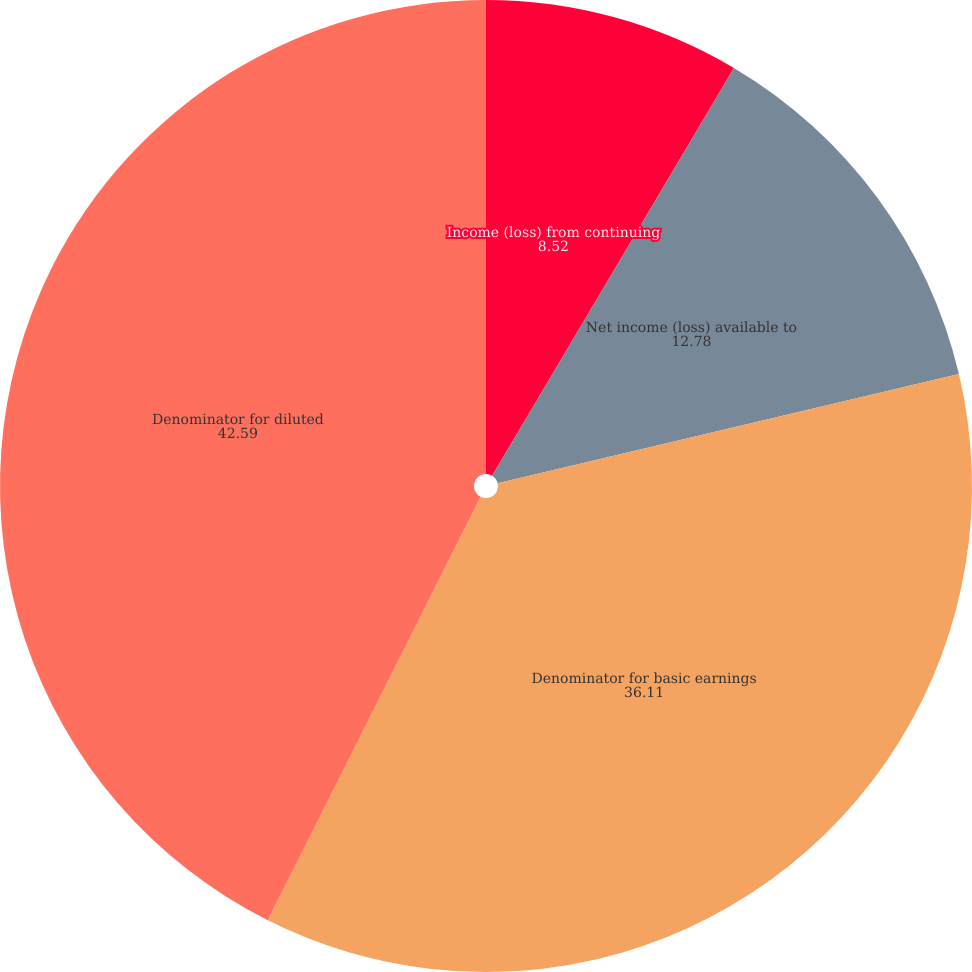<chart> <loc_0><loc_0><loc_500><loc_500><pie_chart><fcel>Income (loss) from continuing<fcel>Net income (loss) available to<fcel>Denominator for basic earnings<fcel>Denominator for diluted<fcel>Net income (loss)<nl><fcel>8.52%<fcel>12.78%<fcel>36.11%<fcel>42.59%<fcel>0.0%<nl></chart> 